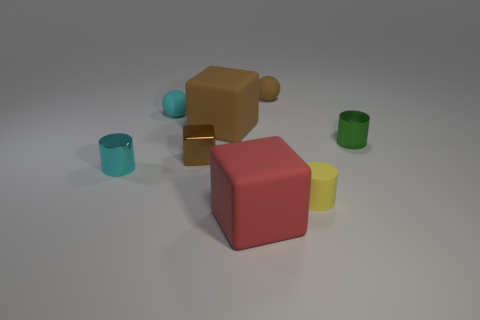What material is the other thing that is the same shape as the small cyan rubber thing?
Offer a terse response. Rubber. There is a large block that is the same color as the tiny cube; what is it made of?
Offer a very short reply. Rubber. Do the large red cube and the yellow thing that is right of the cyan matte thing have the same material?
Make the answer very short. Yes. What color is the cylinder on the left side of the rubber ball that is behind the small cyan rubber thing that is on the right side of the cyan metallic object?
Your answer should be compact. Cyan. Is there any other thing that is the same size as the red object?
Keep it short and to the point. Yes. There is a tiny rubber cylinder; is its color the same as the tiny shiny cylinder right of the red block?
Give a very brief answer. No. What color is the tiny rubber cylinder?
Your answer should be compact. Yellow. There is a brown object that is on the left side of the big rubber block that is on the left side of the block in front of the metal block; what shape is it?
Provide a succinct answer. Cube. What number of other objects are the same color as the tiny cube?
Offer a very short reply. 2. Is the number of small objects that are behind the tiny cyan matte object greater than the number of small green cylinders on the left side of the cyan shiny cylinder?
Make the answer very short. Yes. 